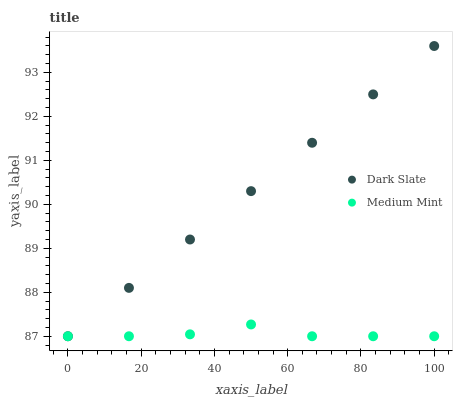Does Medium Mint have the minimum area under the curve?
Answer yes or no. Yes. Does Dark Slate have the maximum area under the curve?
Answer yes or no. Yes. Does Dark Slate have the minimum area under the curve?
Answer yes or no. No. Is Dark Slate the smoothest?
Answer yes or no. Yes. Is Medium Mint the roughest?
Answer yes or no. Yes. Is Dark Slate the roughest?
Answer yes or no. No. Does Medium Mint have the lowest value?
Answer yes or no. Yes. Does Dark Slate have the highest value?
Answer yes or no. Yes. Does Medium Mint intersect Dark Slate?
Answer yes or no. Yes. Is Medium Mint less than Dark Slate?
Answer yes or no. No. Is Medium Mint greater than Dark Slate?
Answer yes or no. No. 